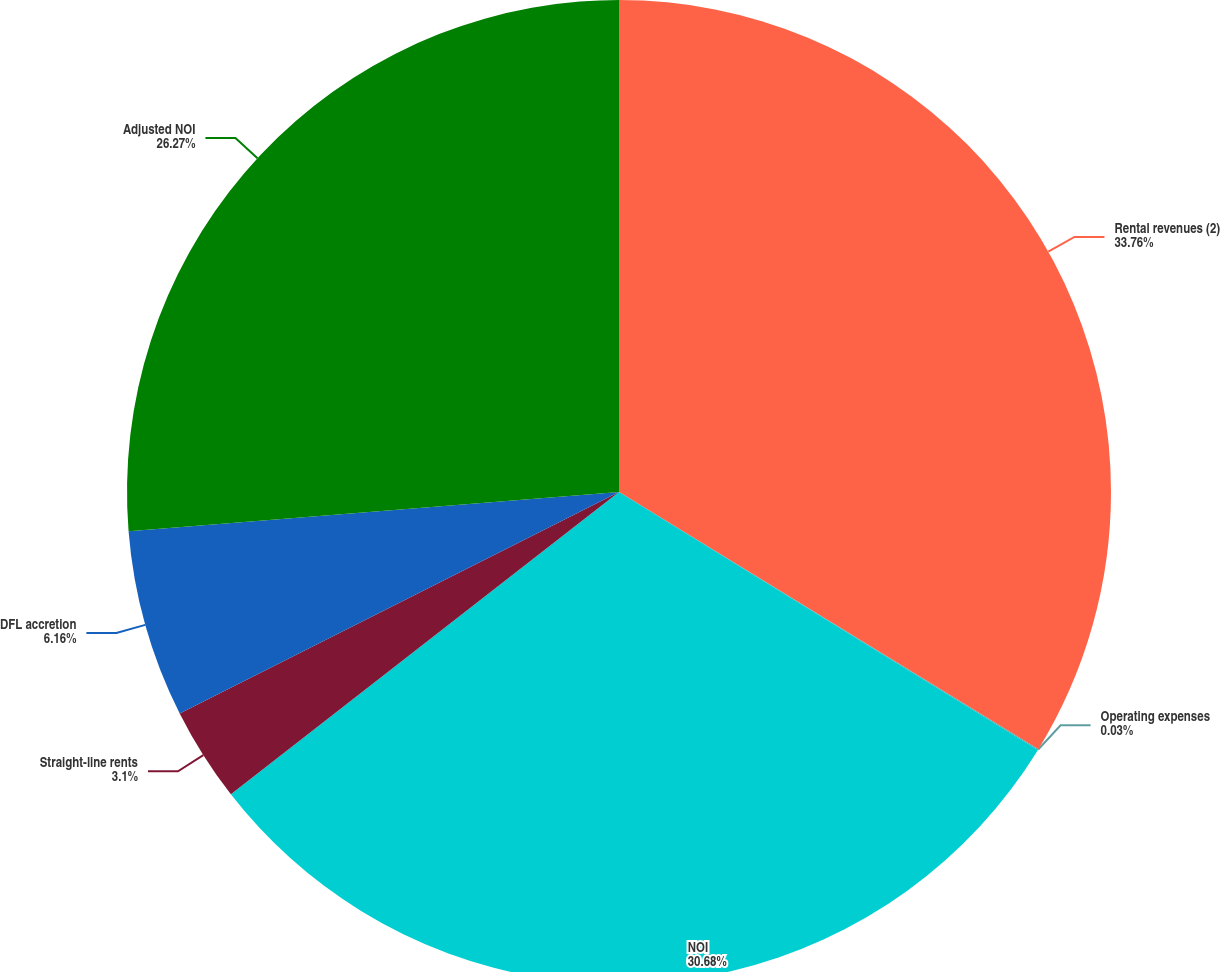Convert chart to OTSL. <chart><loc_0><loc_0><loc_500><loc_500><pie_chart><fcel>Rental revenues (2)<fcel>Operating expenses<fcel>NOI<fcel>Straight-line rents<fcel>DFL accretion<fcel>Adjusted NOI<nl><fcel>33.75%<fcel>0.03%<fcel>30.68%<fcel>3.1%<fcel>6.16%<fcel>26.27%<nl></chart> 